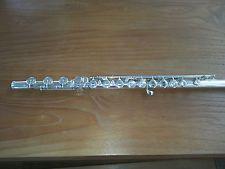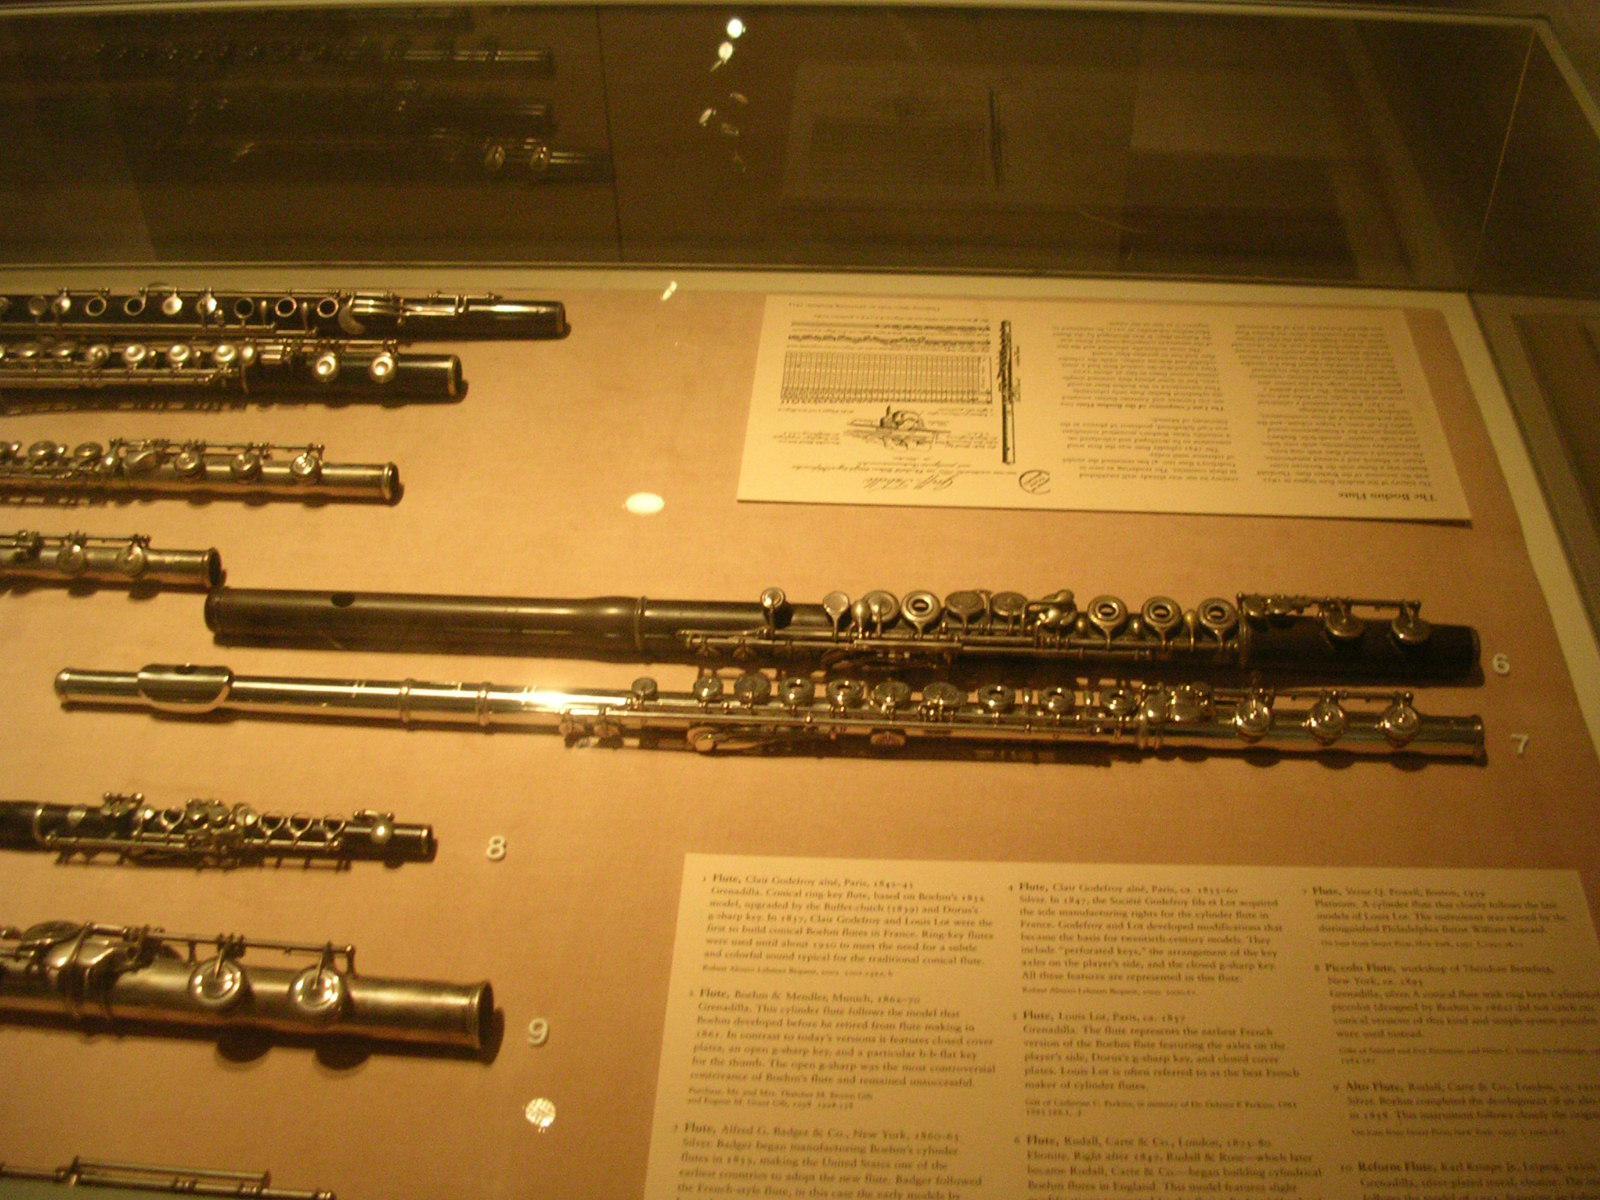The first image is the image on the left, the second image is the image on the right. Evaluate the accuracy of this statement regarding the images: "There is only one instrument in the left image.". Is it true? Answer yes or no. Yes. The first image is the image on the left, the second image is the image on the right. For the images displayed, is the sentence "There are exactly two flutes in the right image." factually correct? Answer yes or no. No. 